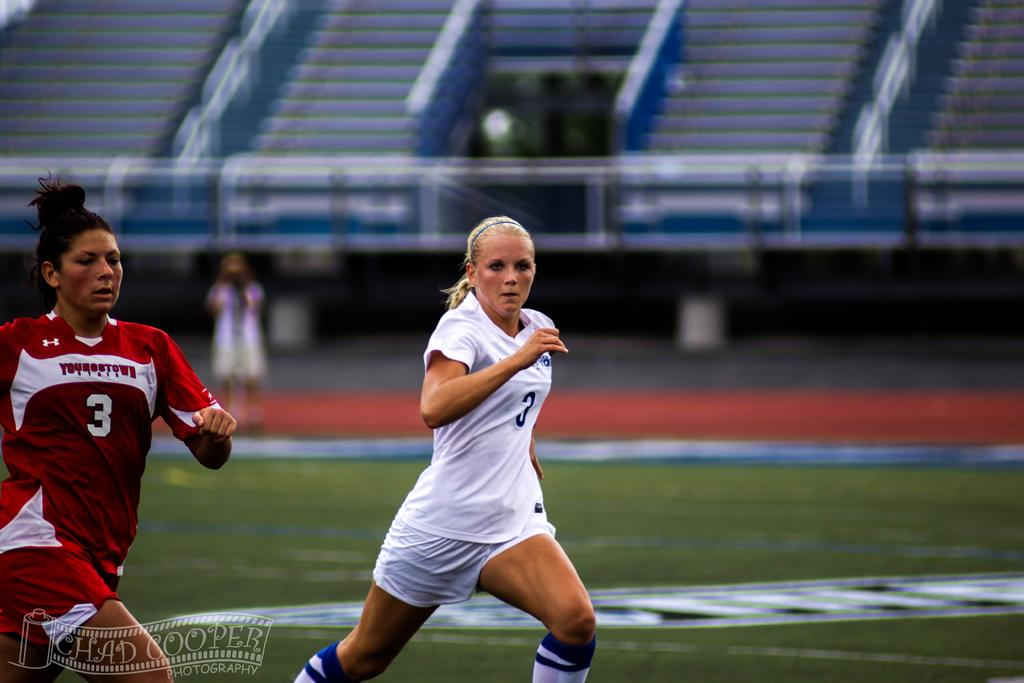What are the people in the image doing? The people in the image are running. Where are the running people located? The running people are on a ground. What can be seen in the background of the image? There is a seating arrangement for the audience in the background of the image. What type of seed is being used by the cook in the image? There is no cook or seed present in the image; it features people running on a ground with a seating arrangement for the audience in the background. 